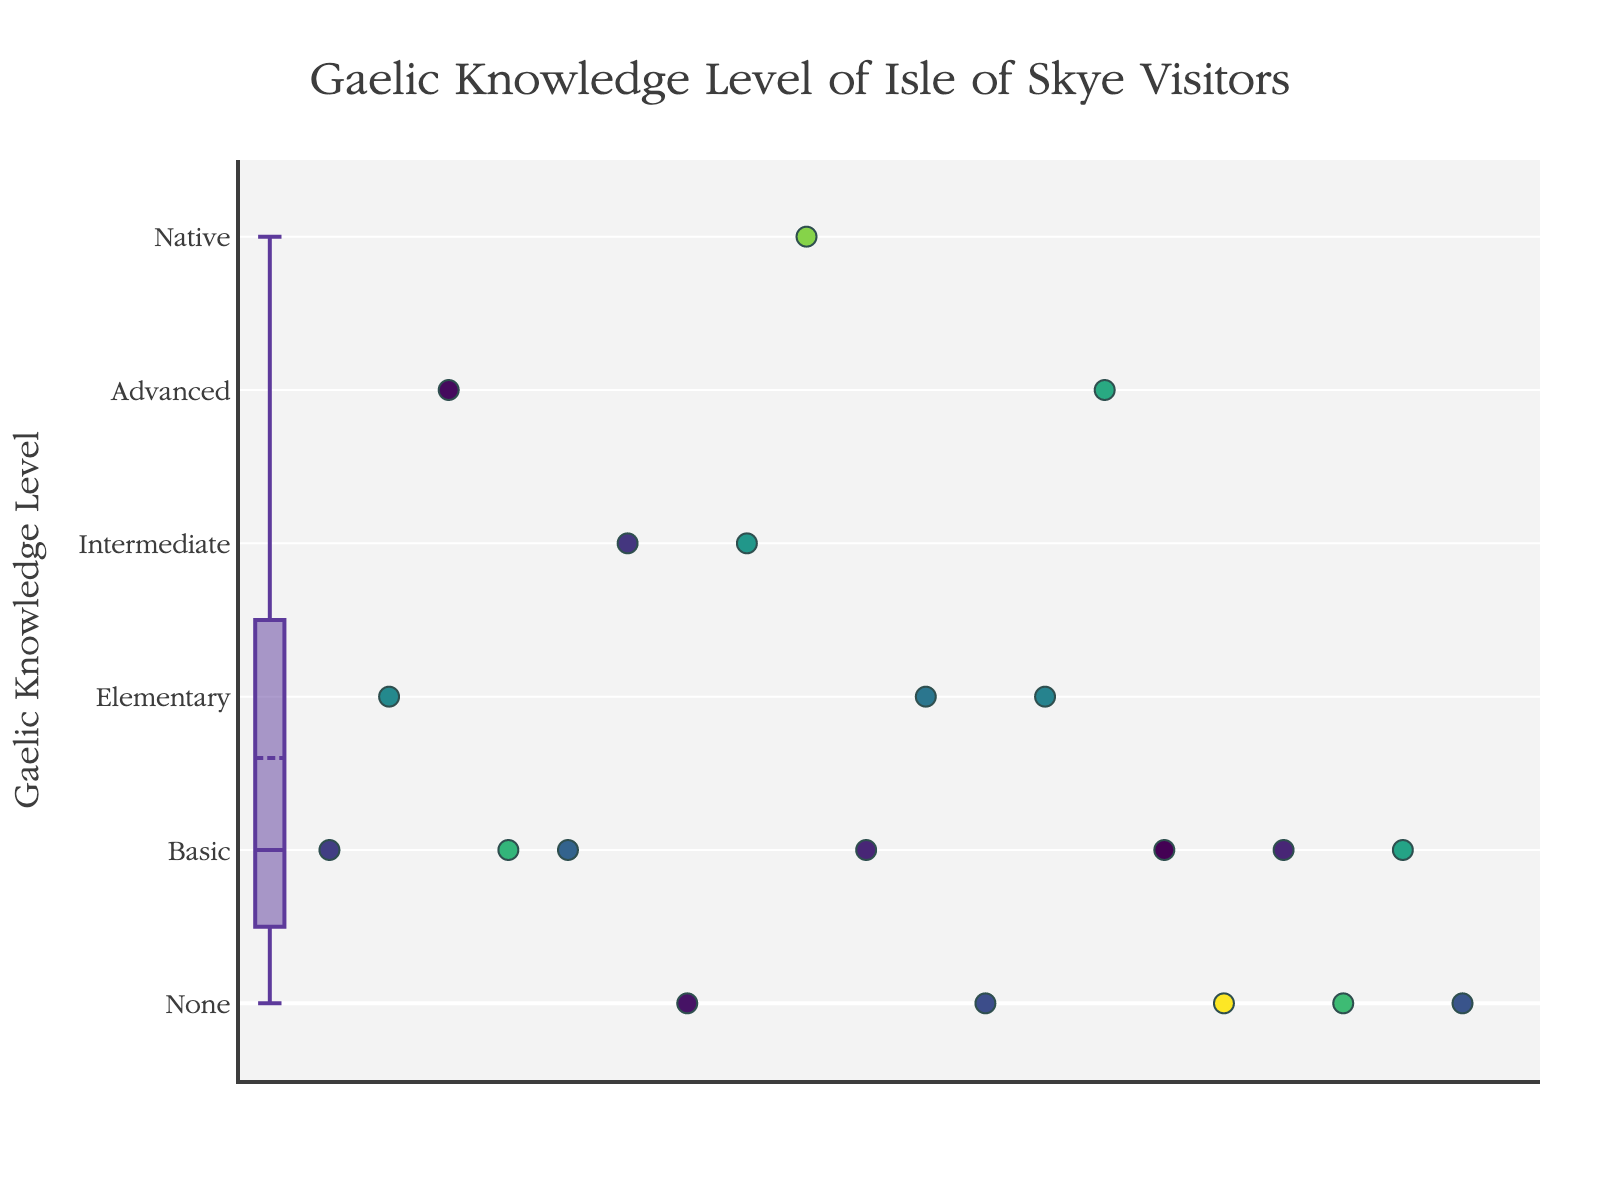What is the title of the figure? The title of the figure is usually displayed at the top of the plot. In this case, it reads "Gaelic Knowledge Level of Isle of Skye Visitors".
Answer: Gaelic Knowledge Level of Isle of Skye Visitors What are the levels of Gaelic knowledge shown on the y-axis? The y-axis shows levels of Gaelic knowledge as 'None', 'Basic', 'Elementary', 'Intermediate', 'Advanced', and 'Native' corresponding to values 0 to 5.
Answer: None, Basic, Elementary, Intermediate, Advanced, Native How many visitors have 'None' level of Gaelic knowledge? Check the scatter points aligned with the 'None' level on the y-axis, which corresponds to 0. Count these points to find the number of visitors.
Answer: 4 What is the median Gaelic knowledge level of the visitors? The median is shown by the line inside the box of the box plot. In this plot, the median lies at the 'Basic' level, which corresponds to 1.
Answer: Basic Which visitor demographic information is displayed when hovering over a scatter point? Hovering over a scatter point reveals the visitor's age, country, and visit month.
Answer: Age, Country, Visit Month Which month has the highest variety of Gaelic knowledge levels among visitors? By examining the scatter points' hover information, identify the month with the widest range of Gaelic knowledge levels. In this plot, the month with the highest variety includes multiple knowledge levels.
Answer: July Are there more visitors with 'Advanced' or 'Elementary' Gaelic knowledge? Count the scatter points at 'Advanced' level (4) and 'Elementary' level (2) on the y-axis. The number of points determines which level has more visitors.
Answer: Advanced What is the average Gaelic knowledge level of visitors in June? Identify scatter points from June, check their y-values for Gaelic knowledge levels, sum them up, and divide by the number of June visitors. The hover information displays the visit month. June visitors' levels are 1, 2, 1, 5, 4, 1. Sum=14, count=6, average=14/6 ≈ 2.33.
Answer: Approximately 2.33 Is there a correlation between the age of visitors and their Gaelic knowledge level? To identify correlation, observe the color gradient of scatter points (representing age) across the Gaelic knowledge levels. Check for any trends or patterns in how age is distributed. No clear age pattern correlating to Gaelic knowledge is visible.
Answer: No clear correlation 